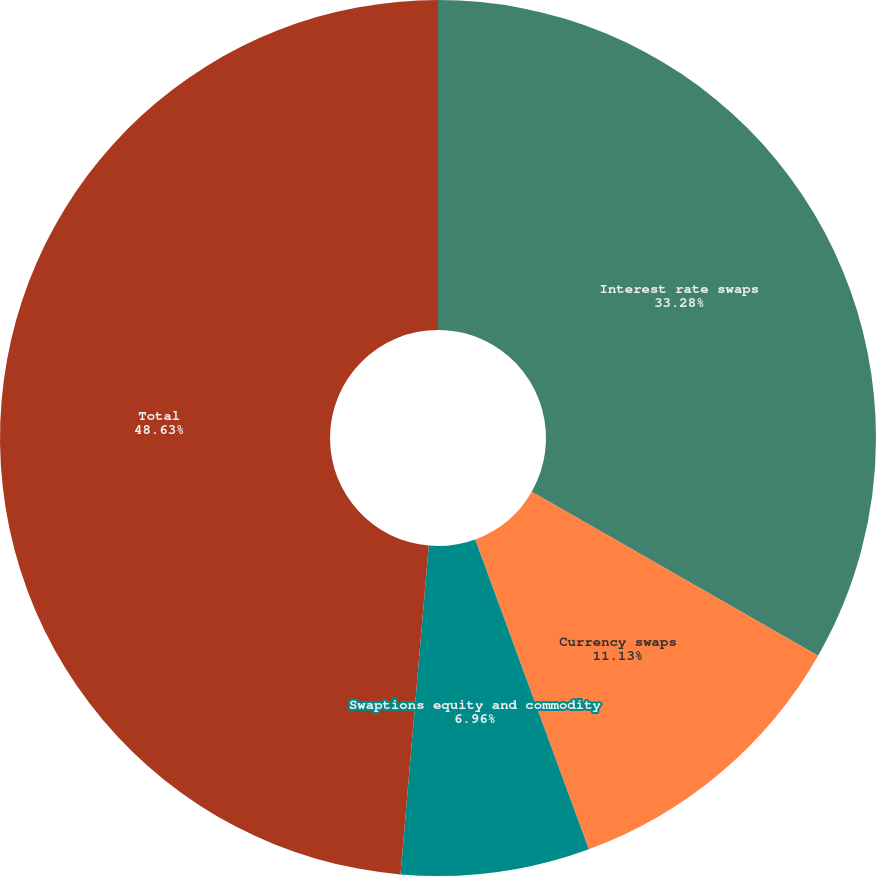<chart> <loc_0><loc_0><loc_500><loc_500><pie_chart><fcel>Interest rate swaps<fcel>Currency swaps<fcel>Swaptions equity and commodity<fcel>Total<nl><fcel>33.28%<fcel>11.13%<fcel>6.96%<fcel>48.64%<nl></chart> 